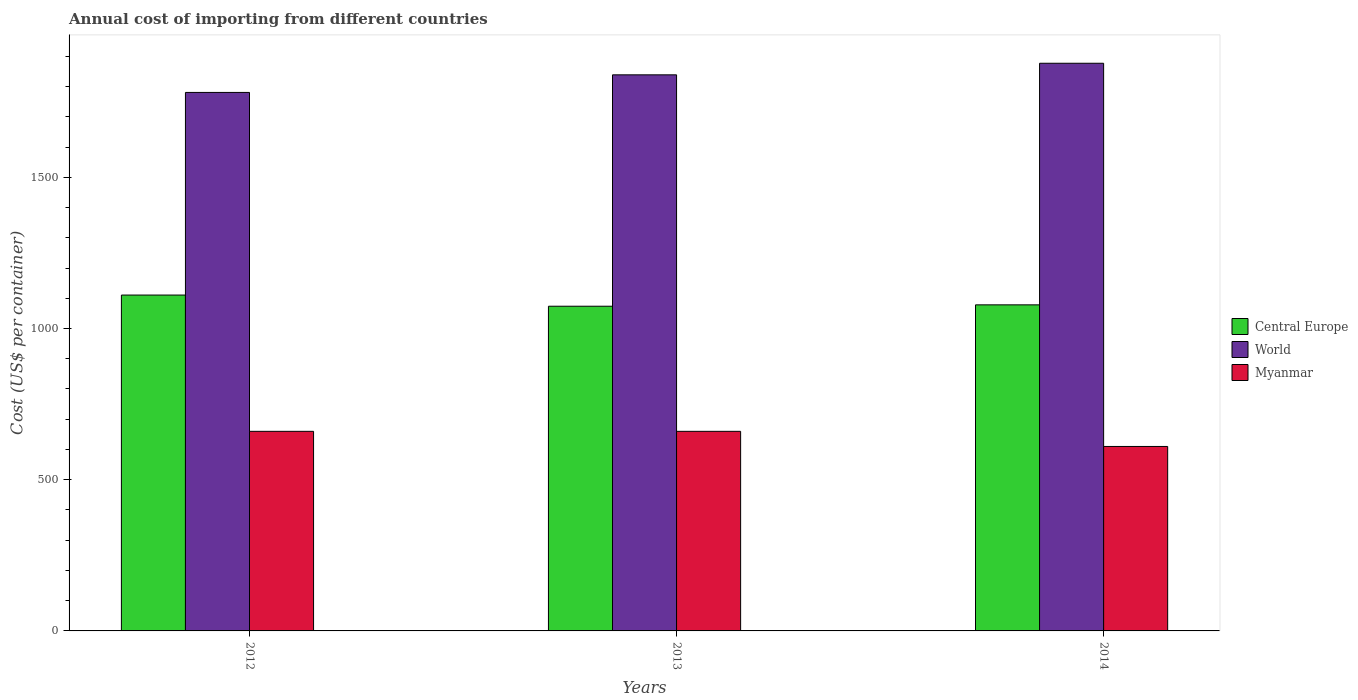How many groups of bars are there?
Offer a terse response. 3. Are the number of bars per tick equal to the number of legend labels?
Ensure brevity in your answer.  Yes. How many bars are there on the 3rd tick from the left?
Offer a very short reply. 3. How many bars are there on the 2nd tick from the right?
Your response must be concise. 3. What is the label of the 2nd group of bars from the left?
Your response must be concise. 2013. What is the total annual cost of importing in Myanmar in 2014?
Your answer should be very brief. 610. Across all years, what is the maximum total annual cost of importing in Myanmar?
Give a very brief answer. 660. Across all years, what is the minimum total annual cost of importing in Central Europe?
Keep it short and to the point. 1073.73. What is the total total annual cost of importing in World in the graph?
Your answer should be compact. 5496.73. What is the difference between the total annual cost of importing in Central Europe in 2012 and that in 2014?
Make the answer very short. 32.36. What is the difference between the total annual cost of importing in Central Europe in 2012 and the total annual cost of importing in World in 2013?
Provide a succinct answer. -728.23. What is the average total annual cost of importing in Central Europe per year?
Your answer should be compact. 1087.55. In the year 2012, what is the difference between the total annual cost of importing in World and total annual cost of importing in Central Europe?
Offer a very short reply. 670.06. In how many years, is the total annual cost of importing in World greater than 1400 US$?
Your response must be concise. 3. What is the ratio of the total annual cost of importing in Central Europe in 2012 to that in 2013?
Keep it short and to the point. 1.03. Is the difference between the total annual cost of importing in World in 2012 and 2013 greater than the difference between the total annual cost of importing in Central Europe in 2012 and 2013?
Make the answer very short. No. What is the difference between the highest and the second highest total annual cost of importing in Central Europe?
Make the answer very short. 32.36. What does the 3rd bar from the left in 2013 represents?
Give a very brief answer. Myanmar. Is it the case that in every year, the sum of the total annual cost of importing in Myanmar and total annual cost of importing in Central Europe is greater than the total annual cost of importing in World?
Make the answer very short. No. How many bars are there?
Give a very brief answer. 9. How many years are there in the graph?
Offer a terse response. 3. What is the difference between two consecutive major ticks on the Y-axis?
Your answer should be very brief. 500. Does the graph contain any zero values?
Ensure brevity in your answer.  No. Does the graph contain grids?
Make the answer very short. No. How many legend labels are there?
Your answer should be compact. 3. How are the legend labels stacked?
Give a very brief answer. Vertical. What is the title of the graph?
Give a very brief answer. Annual cost of importing from different countries. Does "Pacific island small states" appear as one of the legend labels in the graph?
Provide a succinct answer. No. What is the label or title of the X-axis?
Provide a succinct answer. Years. What is the label or title of the Y-axis?
Keep it short and to the point. Cost (US$ per container). What is the Cost (US$ per container) of Central Europe in 2012?
Give a very brief answer. 1110.64. What is the Cost (US$ per container) in World in 2012?
Make the answer very short. 1780.7. What is the Cost (US$ per container) in Myanmar in 2012?
Provide a short and direct response. 660. What is the Cost (US$ per container) of Central Europe in 2013?
Keep it short and to the point. 1073.73. What is the Cost (US$ per container) of World in 2013?
Your answer should be very brief. 1838.86. What is the Cost (US$ per container) in Myanmar in 2013?
Your response must be concise. 660. What is the Cost (US$ per container) in Central Europe in 2014?
Provide a short and direct response. 1078.27. What is the Cost (US$ per container) of World in 2014?
Provide a succinct answer. 1877.17. What is the Cost (US$ per container) in Myanmar in 2014?
Your answer should be compact. 610. Across all years, what is the maximum Cost (US$ per container) of Central Europe?
Provide a succinct answer. 1110.64. Across all years, what is the maximum Cost (US$ per container) in World?
Make the answer very short. 1877.17. Across all years, what is the maximum Cost (US$ per container) in Myanmar?
Provide a succinct answer. 660. Across all years, what is the minimum Cost (US$ per container) in Central Europe?
Offer a very short reply. 1073.73. Across all years, what is the minimum Cost (US$ per container) in World?
Your response must be concise. 1780.7. Across all years, what is the minimum Cost (US$ per container) of Myanmar?
Your answer should be compact. 610. What is the total Cost (US$ per container) of Central Europe in the graph?
Give a very brief answer. 3262.64. What is the total Cost (US$ per container) in World in the graph?
Make the answer very short. 5496.73. What is the total Cost (US$ per container) in Myanmar in the graph?
Ensure brevity in your answer.  1930. What is the difference between the Cost (US$ per container) in Central Europe in 2012 and that in 2013?
Your response must be concise. 36.91. What is the difference between the Cost (US$ per container) in World in 2012 and that in 2013?
Provide a succinct answer. -58.16. What is the difference between the Cost (US$ per container) of Myanmar in 2012 and that in 2013?
Provide a succinct answer. 0. What is the difference between the Cost (US$ per container) of Central Europe in 2012 and that in 2014?
Give a very brief answer. 32.36. What is the difference between the Cost (US$ per container) of World in 2012 and that in 2014?
Your answer should be compact. -96.47. What is the difference between the Cost (US$ per container) of Central Europe in 2013 and that in 2014?
Provide a short and direct response. -4.55. What is the difference between the Cost (US$ per container) in World in 2013 and that in 2014?
Offer a terse response. -38.3. What is the difference between the Cost (US$ per container) in Myanmar in 2013 and that in 2014?
Ensure brevity in your answer.  50. What is the difference between the Cost (US$ per container) in Central Europe in 2012 and the Cost (US$ per container) in World in 2013?
Your answer should be very brief. -728.23. What is the difference between the Cost (US$ per container) in Central Europe in 2012 and the Cost (US$ per container) in Myanmar in 2013?
Offer a terse response. 450.64. What is the difference between the Cost (US$ per container) of World in 2012 and the Cost (US$ per container) of Myanmar in 2013?
Provide a short and direct response. 1120.7. What is the difference between the Cost (US$ per container) in Central Europe in 2012 and the Cost (US$ per container) in World in 2014?
Make the answer very short. -766.53. What is the difference between the Cost (US$ per container) of Central Europe in 2012 and the Cost (US$ per container) of Myanmar in 2014?
Your response must be concise. 500.64. What is the difference between the Cost (US$ per container) in World in 2012 and the Cost (US$ per container) in Myanmar in 2014?
Your response must be concise. 1170.7. What is the difference between the Cost (US$ per container) in Central Europe in 2013 and the Cost (US$ per container) in World in 2014?
Your answer should be very brief. -803.44. What is the difference between the Cost (US$ per container) of Central Europe in 2013 and the Cost (US$ per container) of Myanmar in 2014?
Keep it short and to the point. 463.73. What is the difference between the Cost (US$ per container) of World in 2013 and the Cost (US$ per container) of Myanmar in 2014?
Provide a succinct answer. 1228.86. What is the average Cost (US$ per container) of Central Europe per year?
Your answer should be very brief. 1087.55. What is the average Cost (US$ per container) in World per year?
Your answer should be compact. 1832.24. What is the average Cost (US$ per container) of Myanmar per year?
Offer a very short reply. 643.33. In the year 2012, what is the difference between the Cost (US$ per container) of Central Europe and Cost (US$ per container) of World?
Provide a short and direct response. -670.06. In the year 2012, what is the difference between the Cost (US$ per container) in Central Europe and Cost (US$ per container) in Myanmar?
Your answer should be compact. 450.64. In the year 2012, what is the difference between the Cost (US$ per container) of World and Cost (US$ per container) of Myanmar?
Keep it short and to the point. 1120.7. In the year 2013, what is the difference between the Cost (US$ per container) of Central Europe and Cost (US$ per container) of World?
Offer a terse response. -765.14. In the year 2013, what is the difference between the Cost (US$ per container) of Central Europe and Cost (US$ per container) of Myanmar?
Keep it short and to the point. 413.73. In the year 2013, what is the difference between the Cost (US$ per container) of World and Cost (US$ per container) of Myanmar?
Provide a succinct answer. 1178.86. In the year 2014, what is the difference between the Cost (US$ per container) in Central Europe and Cost (US$ per container) in World?
Provide a succinct answer. -798.89. In the year 2014, what is the difference between the Cost (US$ per container) in Central Europe and Cost (US$ per container) in Myanmar?
Your answer should be very brief. 468.27. In the year 2014, what is the difference between the Cost (US$ per container) in World and Cost (US$ per container) in Myanmar?
Ensure brevity in your answer.  1267.17. What is the ratio of the Cost (US$ per container) of Central Europe in 2012 to that in 2013?
Offer a terse response. 1.03. What is the ratio of the Cost (US$ per container) in World in 2012 to that in 2013?
Provide a succinct answer. 0.97. What is the ratio of the Cost (US$ per container) of Central Europe in 2012 to that in 2014?
Keep it short and to the point. 1.03. What is the ratio of the Cost (US$ per container) of World in 2012 to that in 2014?
Provide a succinct answer. 0.95. What is the ratio of the Cost (US$ per container) of Myanmar in 2012 to that in 2014?
Offer a very short reply. 1.08. What is the ratio of the Cost (US$ per container) of World in 2013 to that in 2014?
Ensure brevity in your answer.  0.98. What is the ratio of the Cost (US$ per container) of Myanmar in 2013 to that in 2014?
Your answer should be compact. 1.08. What is the difference between the highest and the second highest Cost (US$ per container) of Central Europe?
Make the answer very short. 32.36. What is the difference between the highest and the second highest Cost (US$ per container) in World?
Offer a very short reply. 38.3. What is the difference between the highest and the lowest Cost (US$ per container) of Central Europe?
Provide a succinct answer. 36.91. What is the difference between the highest and the lowest Cost (US$ per container) of World?
Provide a short and direct response. 96.47. What is the difference between the highest and the lowest Cost (US$ per container) of Myanmar?
Keep it short and to the point. 50. 